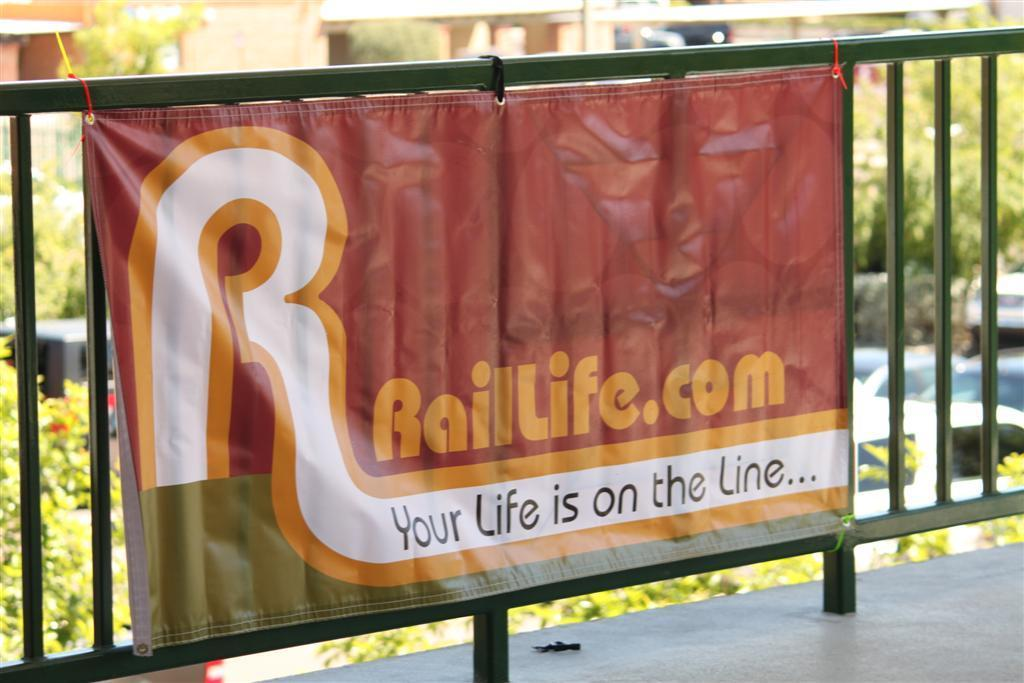<image>
Write a terse but informative summary of the picture. A banner talks about raillife.com and how important it is. 